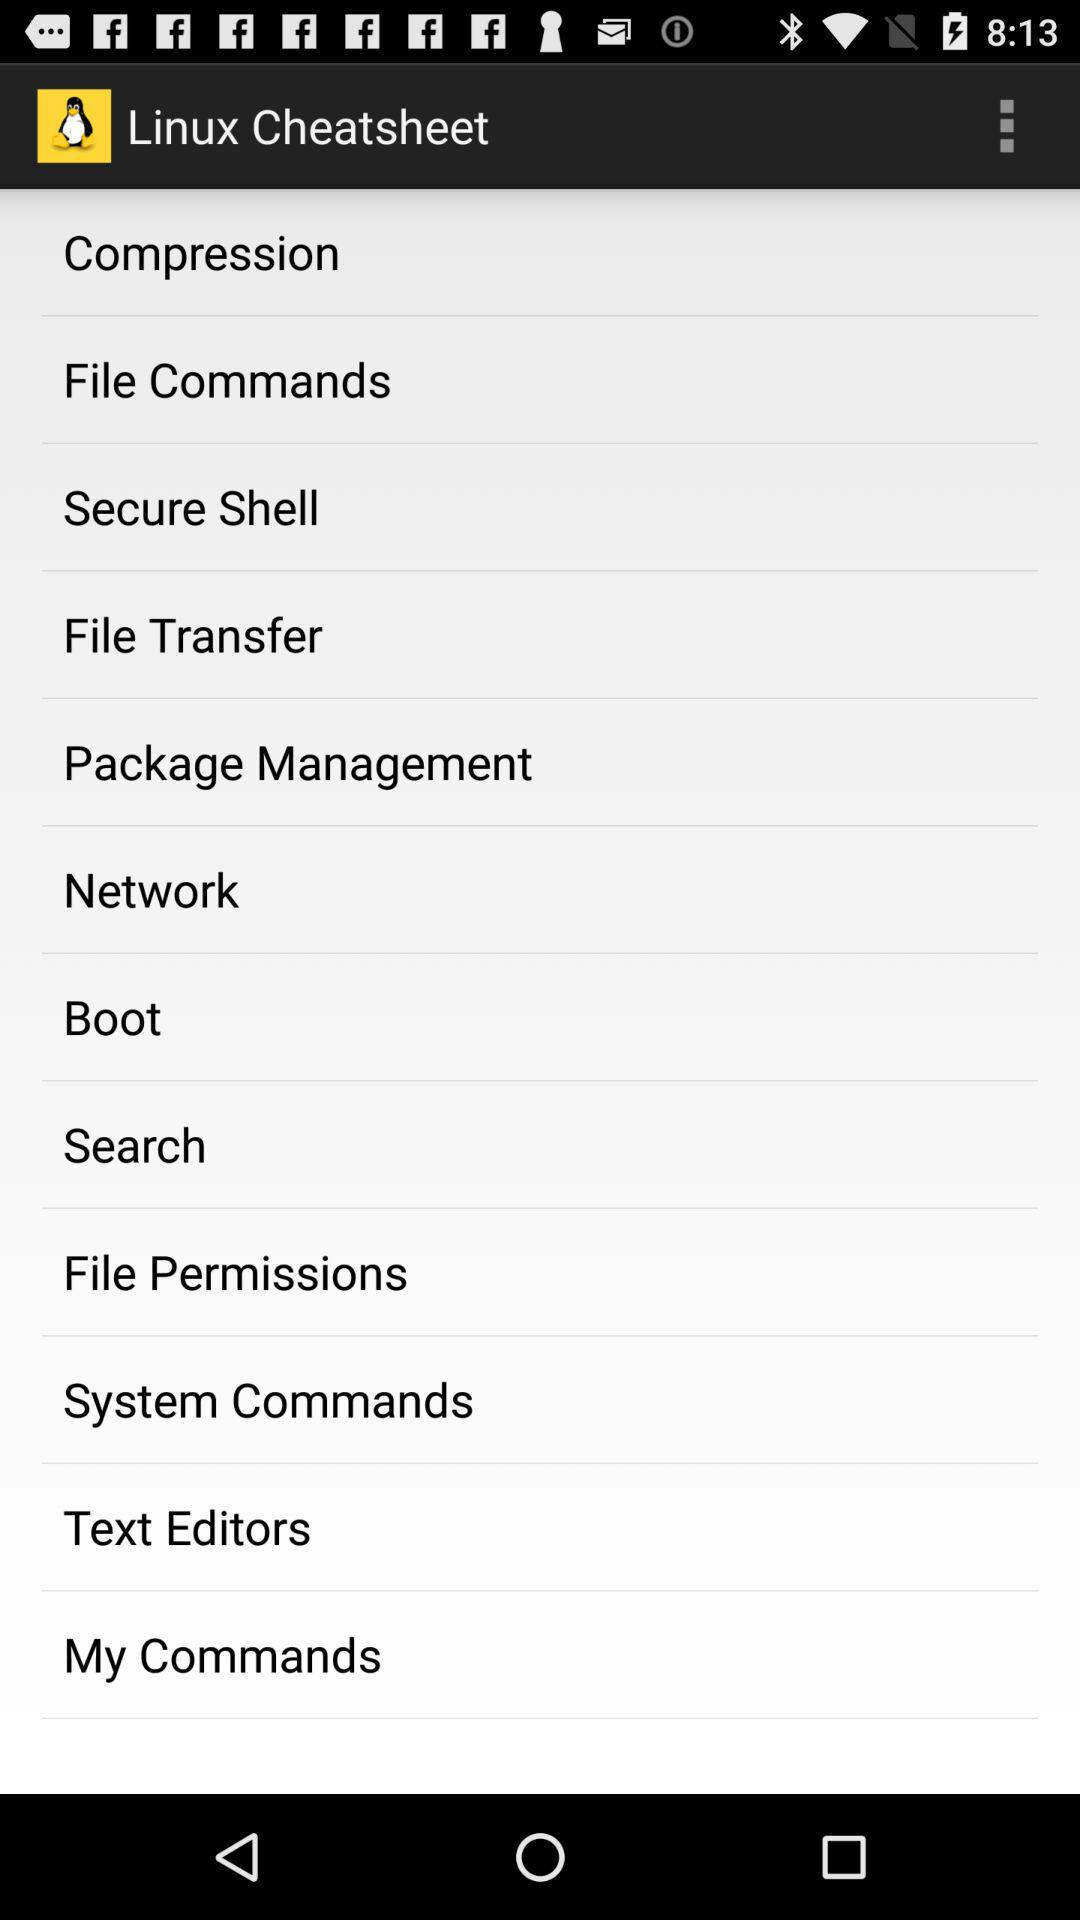What is the application name? The application name is "Linux Cheatsheet". 